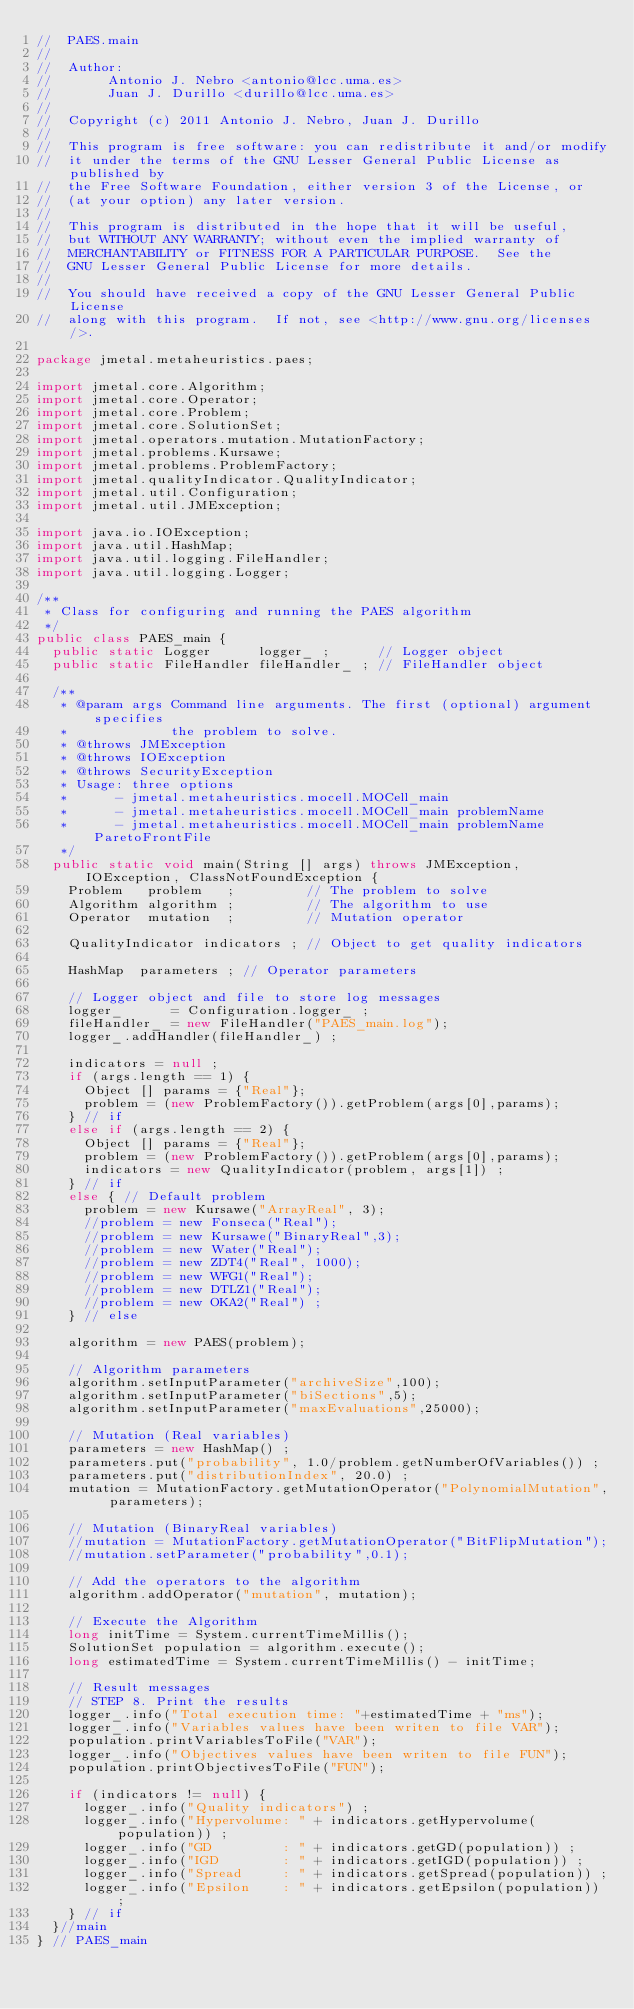<code> <loc_0><loc_0><loc_500><loc_500><_Java_>//  PAES.main
//
//  Author:
//       Antonio J. Nebro <antonio@lcc.uma.es>
//       Juan J. Durillo <durillo@lcc.uma.es>
//
//  Copyright (c) 2011 Antonio J. Nebro, Juan J. Durillo
//
//  This program is free software: you can redistribute it and/or modify
//  it under the terms of the GNU Lesser General Public License as published by
//  the Free Software Foundation, either version 3 of the License, or
//  (at your option) any later version.
//
//  This program is distributed in the hope that it will be useful,
//  but WITHOUT ANY WARRANTY; without even the implied warranty of
//  MERCHANTABILITY or FITNESS FOR A PARTICULAR PURPOSE.  See the
//  GNU Lesser General Public License for more details.
// 
//  You should have received a copy of the GNU Lesser General Public License
//  along with this program.  If not, see <http://www.gnu.org/licenses/>.

package jmetal.metaheuristics.paes;

import jmetal.core.Algorithm;
import jmetal.core.Operator;
import jmetal.core.Problem;
import jmetal.core.SolutionSet;
import jmetal.operators.mutation.MutationFactory;
import jmetal.problems.Kursawe;
import jmetal.problems.ProblemFactory;
import jmetal.qualityIndicator.QualityIndicator;
import jmetal.util.Configuration;
import jmetal.util.JMException;

import java.io.IOException;
import java.util.HashMap;
import java.util.logging.FileHandler;
import java.util.logging.Logger;

/**
 * Class for configuring and running the PAES algorithm
 */
public class PAES_main {
  public static Logger      logger_ ;      // Logger object
  public static FileHandler fileHandler_ ; // FileHandler object

  /**
   * @param args Command line arguments. The first (optional) argument specifies 
   *             the problem to solve.
   * @throws JMException 
   * @throws IOException 
   * @throws SecurityException 
   * Usage: three options
   *      - jmetal.metaheuristics.mocell.MOCell_main
   *      - jmetal.metaheuristics.mocell.MOCell_main problemName
   *      - jmetal.metaheuristics.mocell.MOCell_main problemName ParetoFrontFile
   */
  public static void main(String [] args) throws JMException, IOException, ClassNotFoundException {
    Problem   problem   ;         // The problem to solve
    Algorithm algorithm ;         // The algorithm to use
    Operator  mutation  ;         // Mutation operator
    
    QualityIndicator indicators ; // Object to get quality indicators

    HashMap  parameters ; // Operator parameters

    // Logger object and file to store log messages
    logger_      = Configuration.logger_ ;
    fileHandler_ = new FileHandler("PAES_main.log");
    logger_.addHandler(fileHandler_) ;
    
    indicators = null ;
    if (args.length == 1) {
      Object [] params = {"Real"};
      problem = (new ProblemFactory()).getProblem(args[0],params);
    } // if
    else if (args.length == 2) {
      Object [] params = {"Real"};
      problem = (new ProblemFactory()).getProblem(args[0],params);
      indicators = new QualityIndicator(problem, args[1]) ;
    } // if
    else { // Default problem
      problem = new Kursawe("ArrayReal", 3); 
      //problem = new Fonseca("Real"); 
      //problem = new Kursawe("BinaryReal",3);
      //problem = new Water("Real");
      //problem = new ZDT4("Real", 1000);
      //problem = new WFG1("Real");
      //problem = new DTLZ1("Real");
      //problem = new OKA2("Real") ;
    } // else
    
    algorithm = new PAES(problem);
    
    // Algorithm parameters
    algorithm.setInputParameter("archiveSize",100);
    algorithm.setInputParameter("biSections",5);
    algorithm.setInputParameter("maxEvaluations",25000);
      
    // Mutation (Real variables)
    parameters = new HashMap() ;
    parameters.put("probability", 1.0/problem.getNumberOfVariables()) ;
    parameters.put("distributionIndex", 20.0) ;
    mutation = MutationFactory.getMutationOperator("PolynomialMutation", parameters);                    
    
    // Mutation (BinaryReal variables)
    //mutation = MutationFactory.getMutationOperator("BitFlipMutation");                    
    //mutation.setParameter("probability",0.1);
    
    // Add the operators to the algorithm
    algorithm.addOperator("mutation", mutation);
    
    // Execute the Algorithm 
    long initTime = System.currentTimeMillis();
    SolutionSet population = algorithm.execute();
    long estimatedTime = System.currentTimeMillis() - initTime;
    
    // Result messages 
    // STEP 8. Print the results
    logger_.info("Total execution time: "+estimatedTime + "ms");
    logger_.info("Variables values have been writen to file VAR");
    population.printVariablesToFile("VAR");    
    logger_.info("Objectives values have been writen to file FUN");
    population.printObjectivesToFile("FUN");
  
    if (indicators != null) {
      logger_.info("Quality indicators") ;
      logger_.info("Hypervolume: " + indicators.getHypervolume(population)) ;
      logger_.info("GD         : " + indicators.getGD(population)) ;
      logger_.info("IGD        : " + indicators.getIGD(population)) ;
      logger_.info("Spread     : " + indicators.getSpread(population)) ;
      logger_.info("Epsilon    : " + indicators.getEpsilon(population)) ;  
    } // if
  }//main
} // PAES_main
</code> 